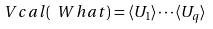Convert formula to latex. <formula><loc_0><loc_0><loc_500><loc_500>\ V c a l ( \ W h a t ) = \langle U _ { 1 } \rangle \cdots \langle U _ { q } \rangle</formula> 